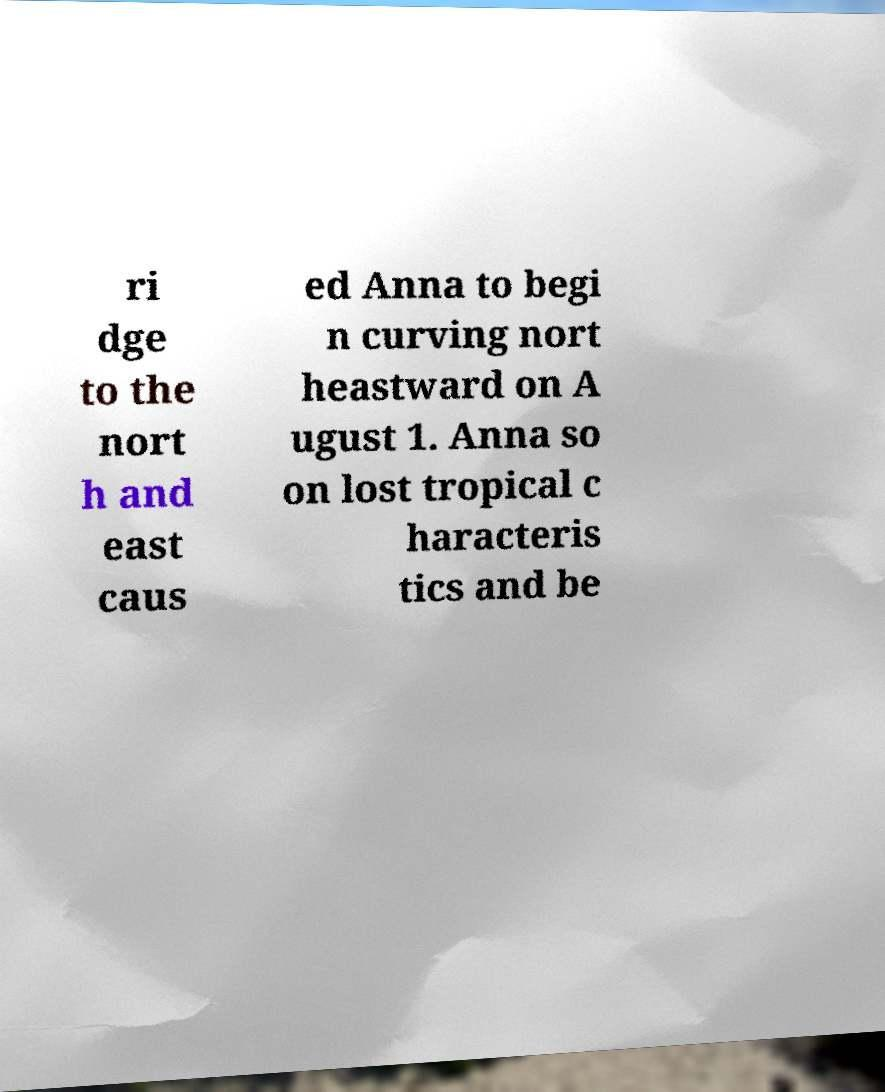Can you accurately transcribe the text from the provided image for me? ri dge to the nort h and east caus ed Anna to begi n curving nort heastward on A ugust 1. Anna so on lost tropical c haracteris tics and be 